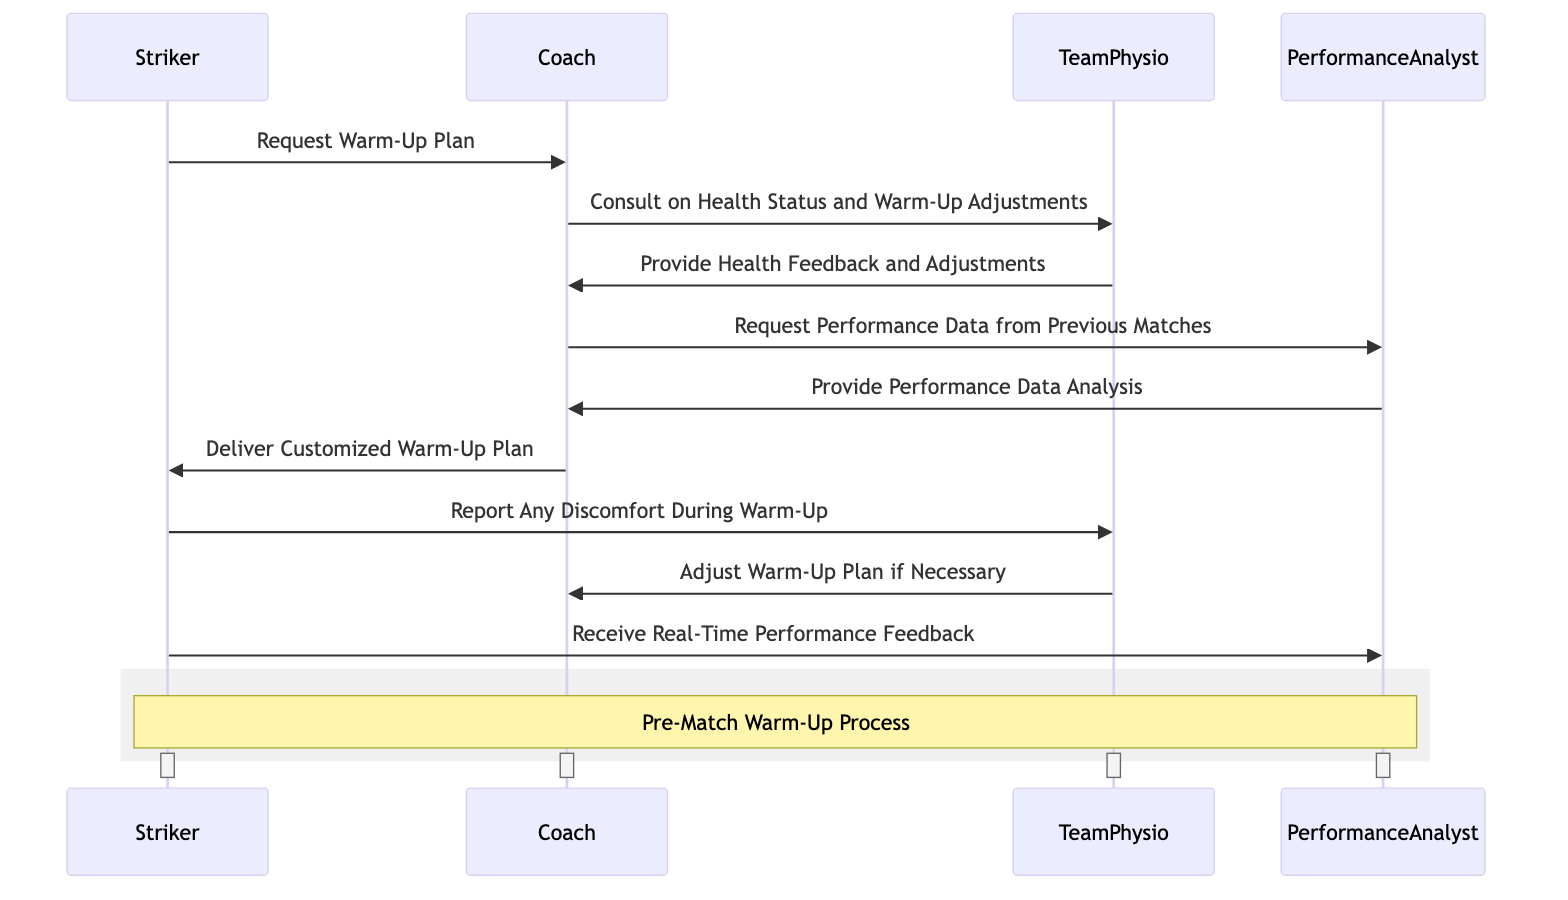What is the first action initiated by the Striker? The first action in the sequence is the Striker requesting a warm-up plan from the Coach. This is evident as the first interaction in the diagram shows the Striker sending this request to the Coach.
Answer: Request Warm-Up Plan Who does the Coach consult regarding health status? The Coach consults the TeamPhysio regarding health status and any necessary adjustments to the warm-up routine. This is shown in the second interaction where the Coach is directing a query to the TeamPhysio.
Answer: TeamPhysio What information does the Performance Analyst provide to the Coach? The Performance Analyst provides performance data analysis to the Coach. This is indicated in the fifth interaction where the Coach receives this feedback from the Performance Analyst.
Answer: Provide Performance Data Analysis How many total interactions are shown in the diagram? There are a total of eight interactions represented in the sequence diagram. By counting each of the arrows representing messages exchanged between the actors, we arrive at this number.
Answer: Eight What adjustment might the TeamPhysio make during the warm-up? The TeamPhysio may adjust the warm-up plan if necessary, based on the information received from the Striker regarding any discomfort during the warm-up. This is depicted in the eighth interaction between the TeamPhysio and the Coach.
Answer: Adjust Warm-Up Plan What is the role of the Performance Analyst in this process? The Performance Analyst's role is to monitor and analyze performance data, which includes providing analysis from previous matches to the Coach. This is inferred from the interactions specifically involving the Performance Analyst in the diagram.
Answer: Monitors and analyzes performance data At which point does the Striker report discomfort? The Striker reports any discomfort during the warm-up right after receiving the customized warm-up plan from the Coach. This is shown as the sixth to seventh interaction, demonstrating the sequence of actions.
Answer: Report Any Discomfort During Warm-Up What is the final step in the warm-up sequence for the Striker? The final step in the sequence for the Striker is to receive real-time performance feedback from the Performance Analyst. This occurs as the last interaction outlined in the diagram where the Striker engages with the Performance Analyst.
Answer: Receive Real-Time Performance Feedback 